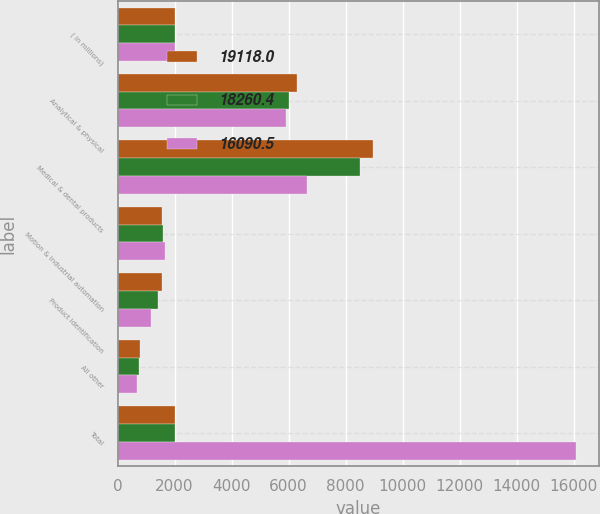Convert chart to OTSL. <chart><loc_0><loc_0><loc_500><loc_500><stacked_bar_chart><ecel><fcel>( in millions)<fcel>Analytical & physical<fcel>Medical & dental products<fcel>Motion & industrial automation<fcel>Product identification<fcel>All other<fcel>Total<nl><fcel>19118<fcel>2013<fcel>6278.5<fcel>8958<fcel>1559.1<fcel>1551.5<fcel>770.9<fcel>2011<nl><fcel>18260.4<fcel>2012<fcel>6000.8<fcel>8509.1<fcel>1592.4<fcel>1410.3<fcel>747.8<fcel>2011<nl><fcel>16090.5<fcel>2011<fcel>5920.9<fcel>6653.5<fcel>1677.1<fcel>1162.1<fcel>676.9<fcel>16090.5<nl></chart> 